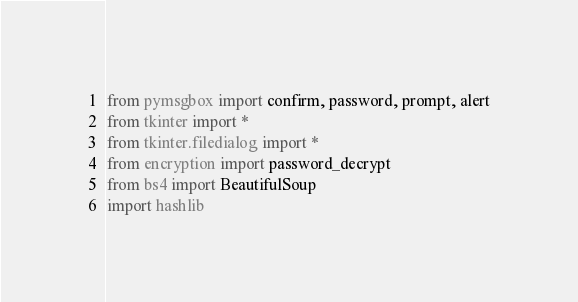Convert code to text. <code><loc_0><loc_0><loc_500><loc_500><_Python_>from pymsgbox import confirm, password, prompt, alert
from tkinter import *
from tkinter.filedialog import *
from encryption import password_decrypt
from bs4 import BeautifulSoup
import hashlib</code> 